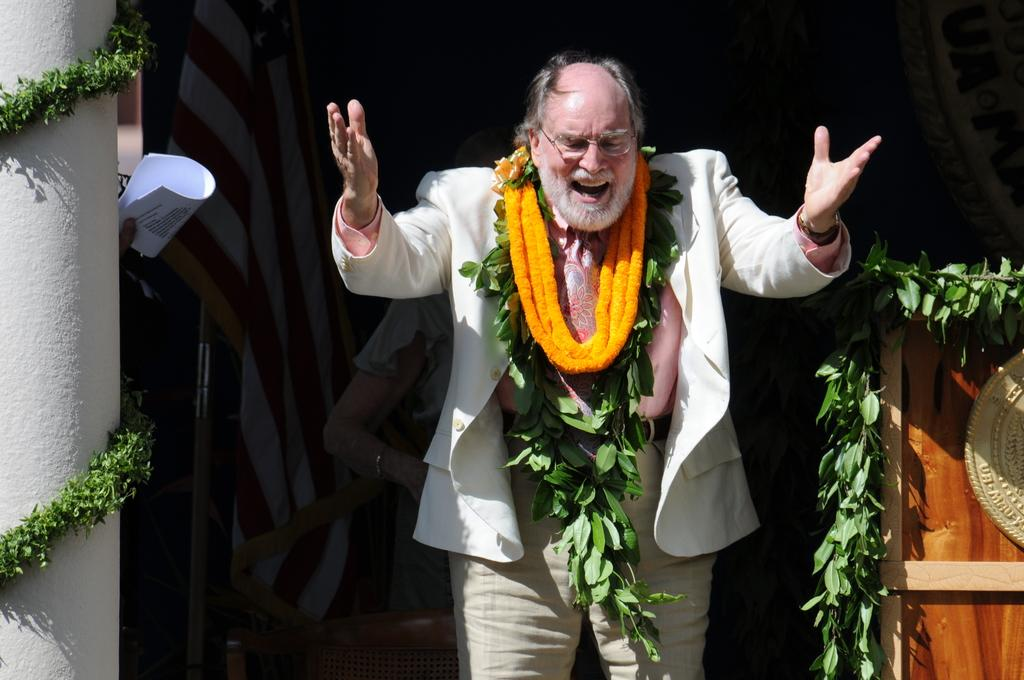What is the man in the image doing? The man is standing in the image. What is unique about the man's appearance? The man has garlands around his neck. What can be seen in the background of the image? There is a pillar, leaves, a podium, a chair, and a woman in the background of the image. What might the person holding papers be doing? The person holding papers might be giving a presentation or speech. What type of humor can be seen in the iron used by the man in the image? There is no iron present in the image, and the man is not using any humor. 